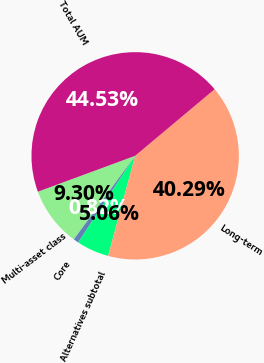Convert chart. <chart><loc_0><loc_0><loc_500><loc_500><pie_chart><fcel>Multi-asset class<fcel>Core<fcel>Alternatives subtotal<fcel>Long-term<fcel>Total AUM<nl><fcel>9.3%<fcel>0.82%<fcel>5.06%<fcel>40.29%<fcel>44.53%<nl></chart> 